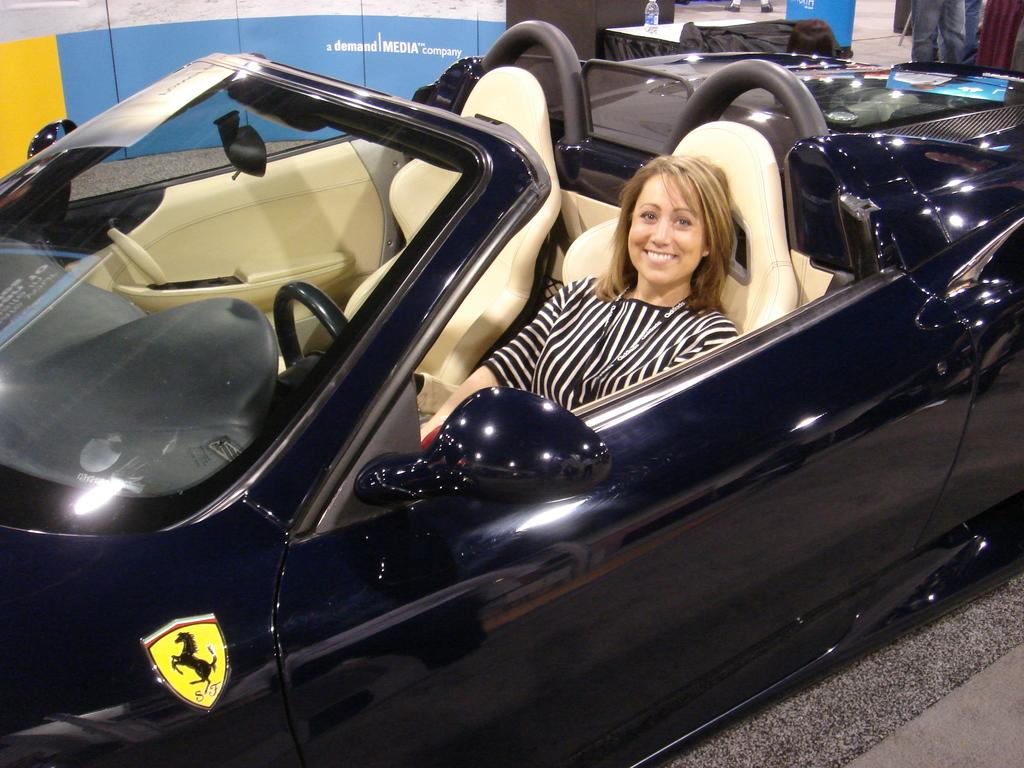What is the main subject in the foreground of the image? There is a woman sitting inside a car in the foreground of the image. What is the car's position in relation to the desk? The car appears to be parked near a desk. What can be seen in the background of the image? There is a poster and a person in the background of the image. What type of fold is the woman teaching in the image? There is no fold being taught in the image, nor is there any indication that the woman is a teacher. Is there a ship visible in the image? No, there is no ship present in the image. 